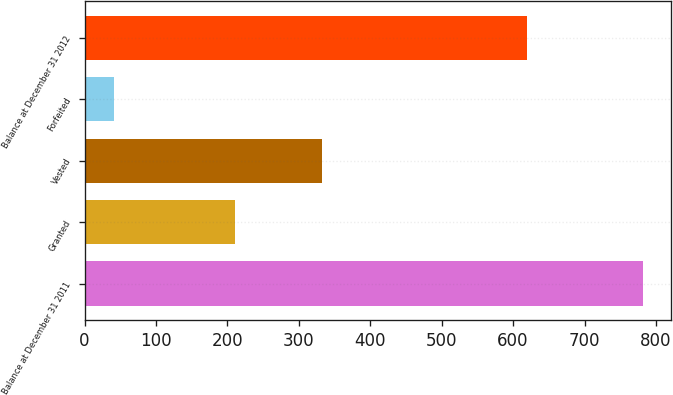Convert chart to OTSL. <chart><loc_0><loc_0><loc_500><loc_500><bar_chart><fcel>Balance at December 31 2011<fcel>Granted<fcel>Vested<fcel>Forfeited<fcel>Balance at December 31 2012<nl><fcel>782<fcel>211<fcel>333<fcel>41<fcel>619<nl></chart> 